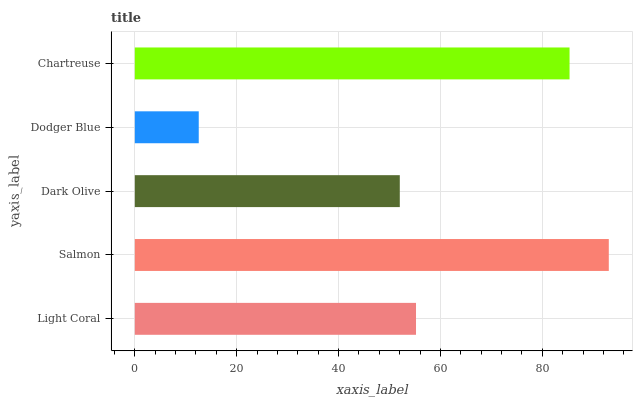Is Dodger Blue the minimum?
Answer yes or no. Yes. Is Salmon the maximum?
Answer yes or no. Yes. Is Dark Olive the minimum?
Answer yes or no. No. Is Dark Olive the maximum?
Answer yes or no. No. Is Salmon greater than Dark Olive?
Answer yes or no. Yes. Is Dark Olive less than Salmon?
Answer yes or no. Yes. Is Dark Olive greater than Salmon?
Answer yes or no. No. Is Salmon less than Dark Olive?
Answer yes or no. No. Is Light Coral the high median?
Answer yes or no. Yes. Is Light Coral the low median?
Answer yes or no. Yes. Is Chartreuse the high median?
Answer yes or no. No. Is Chartreuse the low median?
Answer yes or no. No. 